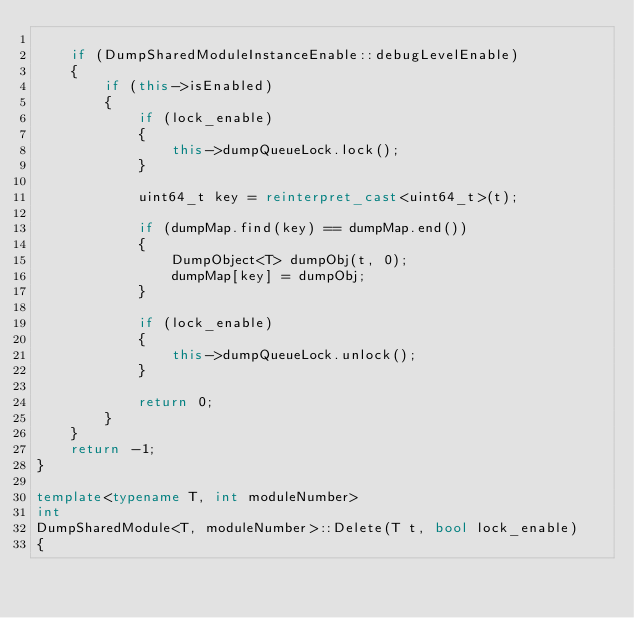Convert code to text. <code><loc_0><loc_0><loc_500><loc_500><_C++_>
    if (DumpSharedModuleInstanceEnable::debugLevelEnable)
    {
        if (this->isEnabled)
        {
            if (lock_enable)
            {
                this->dumpQueueLock.lock();
            }

            uint64_t key = reinterpret_cast<uint64_t>(t);

            if (dumpMap.find(key) == dumpMap.end())
            {
                DumpObject<T> dumpObj(t, 0);
                dumpMap[key] = dumpObj;
            }

            if (lock_enable)
            {
                this->dumpQueueLock.unlock();
            }

            return 0;
        }
    }
    return -1;
}

template<typename T, int moduleNumber>
int
DumpSharedModule<T, moduleNumber>::Delete(T t, bool lock_enable)
{</code> 